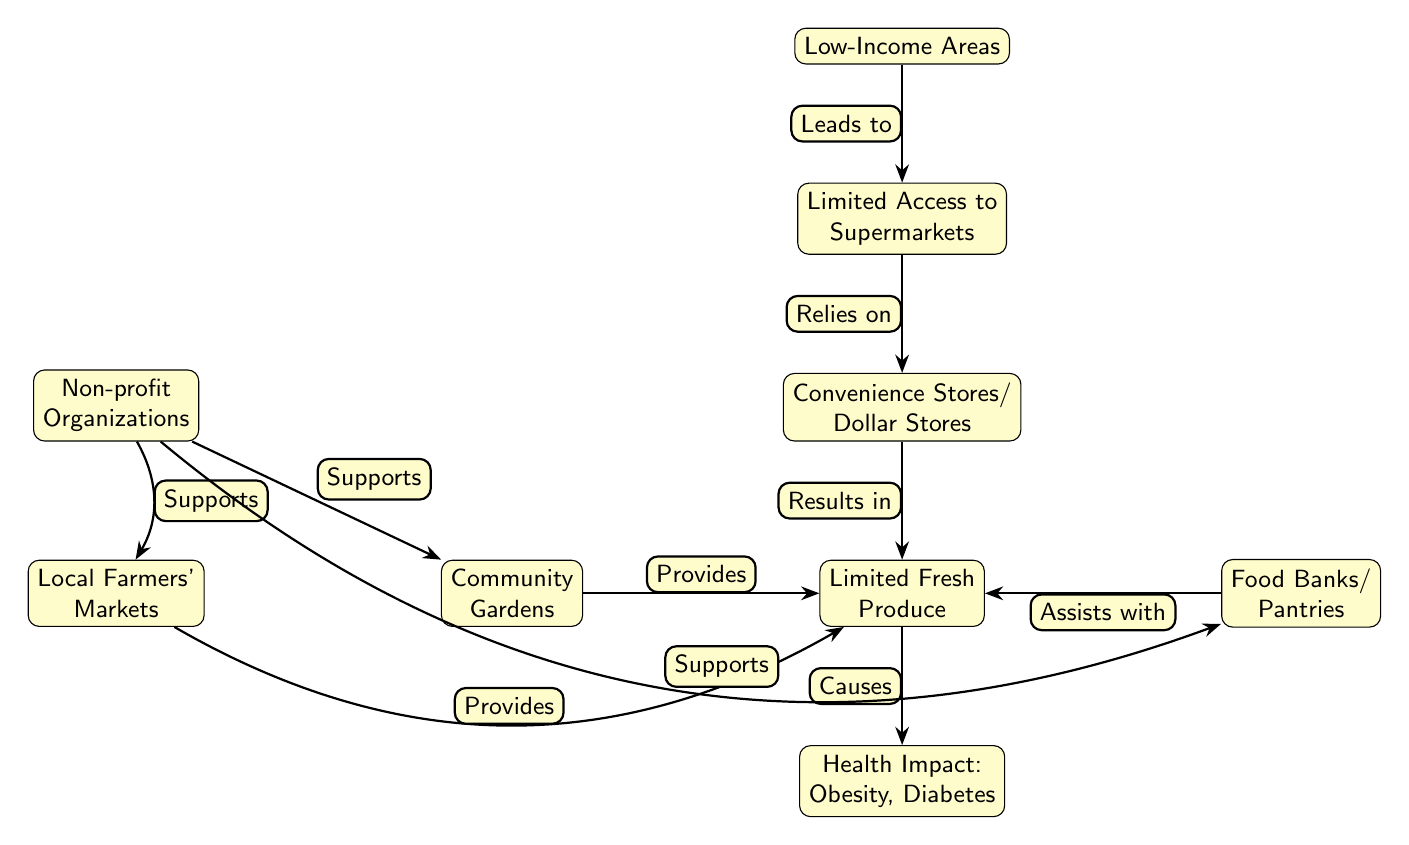What is the first node in the diagram? The first node in the diagram is "Low-Income Areas," which can be identified as the top node in the flow of the food chain.
Answer: Low-Income Areas How many nodes are in the diagram? By counting each distinct labeled box in the diagram, there are a total of 9 nodes represented.
Answer: 9 What does "Limited Access to Supermarkets" rely on? According to the diagram, "Limited Access to Supermarkets" relies on "Low-Income Areas," which is connected directly to it by an edge indicating a dependence relationship.
Answer: Low-Income Areas What health impacts are caused by "Limited Fresh Produce"? The diagram indicates that "Limited Fresh Produce" causes health impacts like "Obesity, Diabetes," which are the consequences noted directly below that node.
Answer: Obesity, Diabetes What node provides fresh produce alongside community gardens? The diagram shows that "Local Farmers' Markets" also provides fresh produce as indicated by the edge connecting it to "Limited Fresh Produce."
Answer: Local Farmers' Markets Which entity supports multiple nodes in the diagram? The "Non-profit Organizations" node supports three other nodes: "Community Gardens," "Local Farmers' Markets," and "Food Banks/Pantries," shown by the edges going from it to these nodes.
Answer: Non-profit Organizations What is the relationship between convenience stores/dollar stores and limited fresh produce? The diagram indicates that "Convenience Stores/Dollar Stores" result in "Limited Fresh Produce," emphasizing a negative outcome tied to their presence in low-income areas.
Answer: Results in How do food banks and pantries assist in the food chain? According to the diagram, "Food Banks/Pantries" assists with "Limited Fresh Produce," illustrating that they play a supportive role by providing food resources.
Answer: Assists with What is the relationship between community gardens and limited fresh produce? The diagram labels the relationship as "Provides," showing that community gardens contribute directly to the supply of limited fresh produce available in low-income areas.
Answer: Provides 